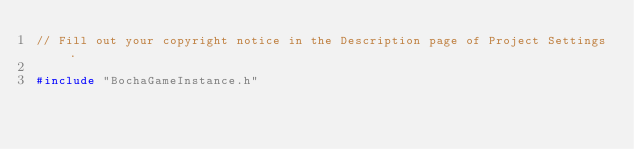Convert code to text. <code><loc_0><loc_0><loc_500><loc_500><_C++_>// Fill out your copyright notice in the Description page of Project Settings.

#include "BochaGameInstance.h"




</code> 